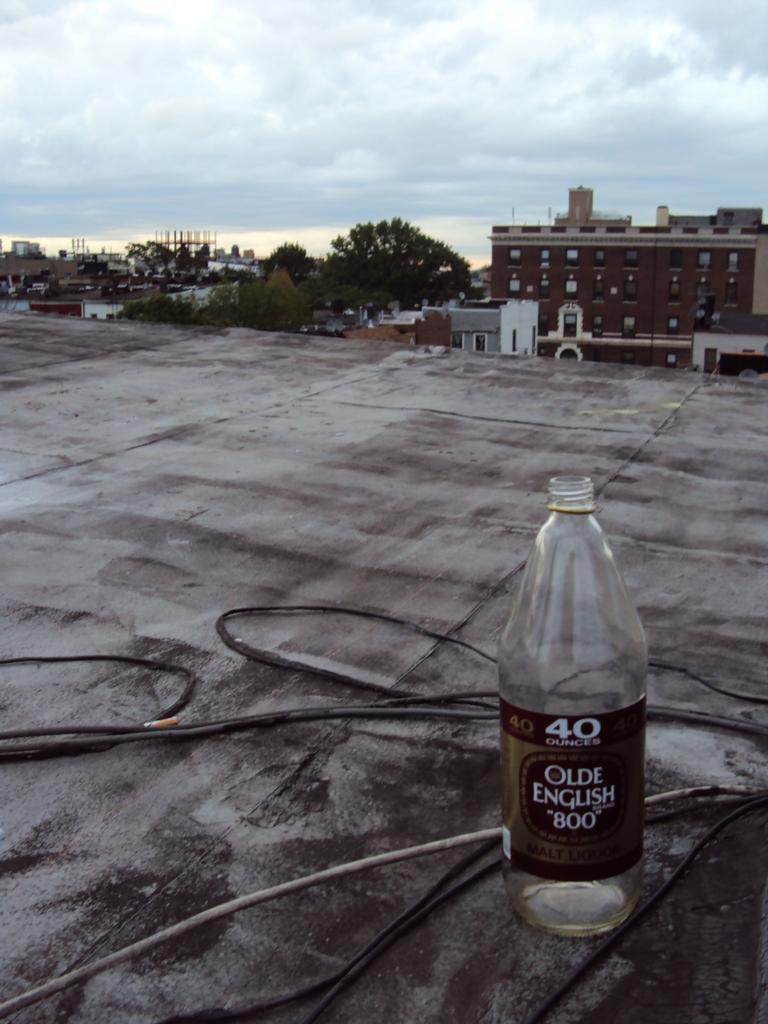<image>
Share a concise interpretation of the image provided. A bottle of Olde English malt liquor is sitting on a desolate roof surrounded by wires. 